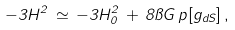<formula> <loc_0><loc_0><loc_500><loc_500>- 3 H ^ { 2 } \, \simeq \, - 3 H _ { 0 } ^ { 2 } \, + \, 8 \pi G \, p [ g _ { d S } ] \, ,</formula> 